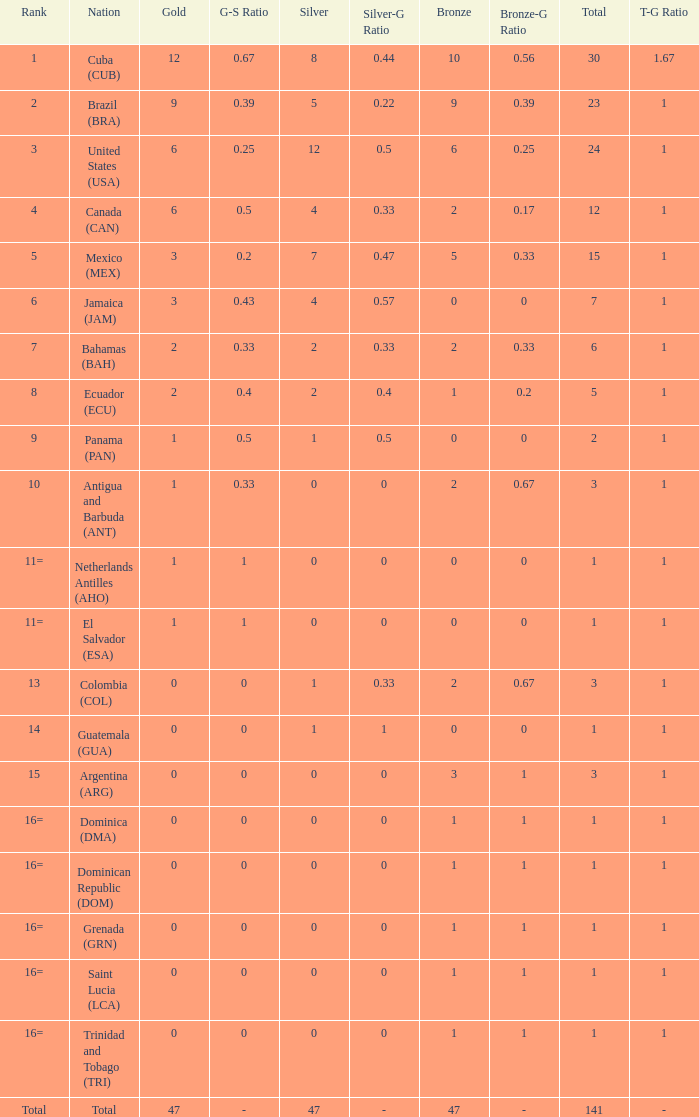How many bronzes have a Nation of jamaica (jam), and a Total smaller than 7? 0.0. 